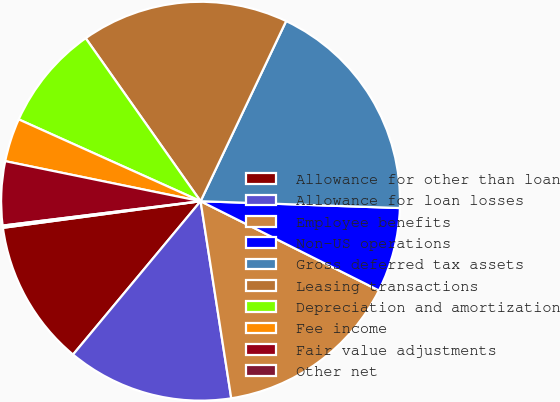Convert chart to OTSL. <chart><loc_0><loc_0><loc_500><loc_500><pie_chart><fcel>Allowance for other than loan<fcel>Allowance for loan losses<fcel>Employee benefits<fcel>Non-US operations<fcel>Gross deferred tax assets<fcel>Leasing transactions<fcel>Depreciation and amortization<fcel>Fee income<fcel>Fair value adjustments<fcel>Other net<nl><fcel>11.83%<fcel>13.5%<fcel>15.16%<fcel>6.84%<fcel>18.49%<fcel>16.83%<fcel>8.5%<fcel>3.51%<fcel>5.17%<fcel>0.18%<nl></chart> 